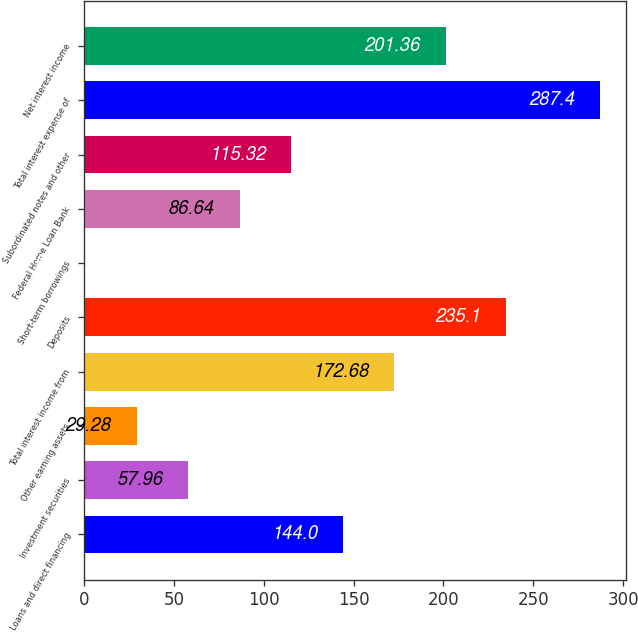Convert chart. <chart><loc_0><loc_0><loc_500><loc_500><bar_chart><fcel>Loans and direct financing<fcel>Investment securities<fcel>Other earning assets<fcel>Total interest income from<fcel>Deposits<fcel>Short-term borrowings<fcel>Federal Home Loan Bank<fcel>Subordinated notes and other<fcel>Total interest expense of<fcel>Net interest income<nl><fcel>144<fcel>57.96<fcel>29.28<fcel>172.68<fcel>235.1<fcel>0.6<fcel>86.64<fcel>115.32<fcel>287.4<fcel>201.36<nl></chart> 